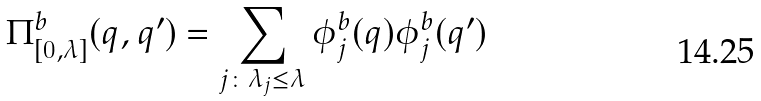<formula> <loc_0><loc_0><loc_500><loc_500>\Pi ^ { b } _ { [ 0 , \lambda ] } ( q , q ^ { \prime } ) = \sum _ { j \colon \lambda _ { j } \leq \lambda } \phi _ { j } ^ { b } ( q ) \phi _ { j } ^ { b } ( q ^ { \prime } )</formula> 